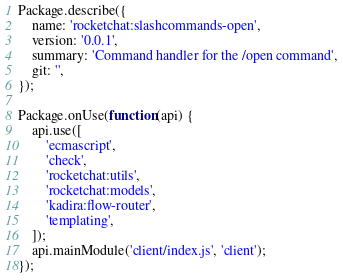<code> <loc_0><loc_0><loc_500><loc_500><_JavaScript_>Package.describe({
	name: 'rocketchat:slashcommands-open',
	version: '0.0.1',
	summary: 'Command handler for the /open command',
	git: '',
});

Package.onUse(function(api) {
	api.use([
		'ecmascript',
		'check',
		'rocketchat:utils',
		'rocketchat:models',
		'kadira:flow-router',
		'templating',
	]);
	api.mainModule('client/index.js', 'client');
});
</code> 